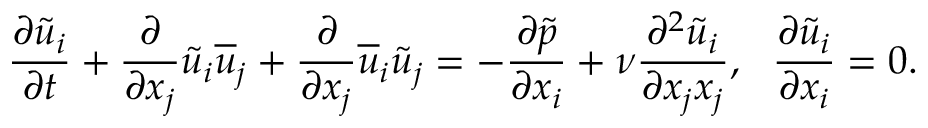Convert formula to latex. <formula><loc_0><loc_0><loc_500><loc_500>\frac { \partial \tilde { u } _ { i } } { \partial t } + \frac { \partial } { \partial x _ { j } } \tilde { u } _ { i } \overline { u } _ { j } + \frac { \partial } { \partial x _ { j } } \overline { u } _ { i } \tilde { u } _ { j } = - \frac { \partial \tilde { p } } { \partial x _ { i } } + \nu \frac { \partial ^ { 2 } \tilde { u } _ { i } } { \partial x _ { j } x _ { j } } , \frac { \partial \tilde { u } _ { i } } { \partial x _ { i } } = 0 .</formula> 